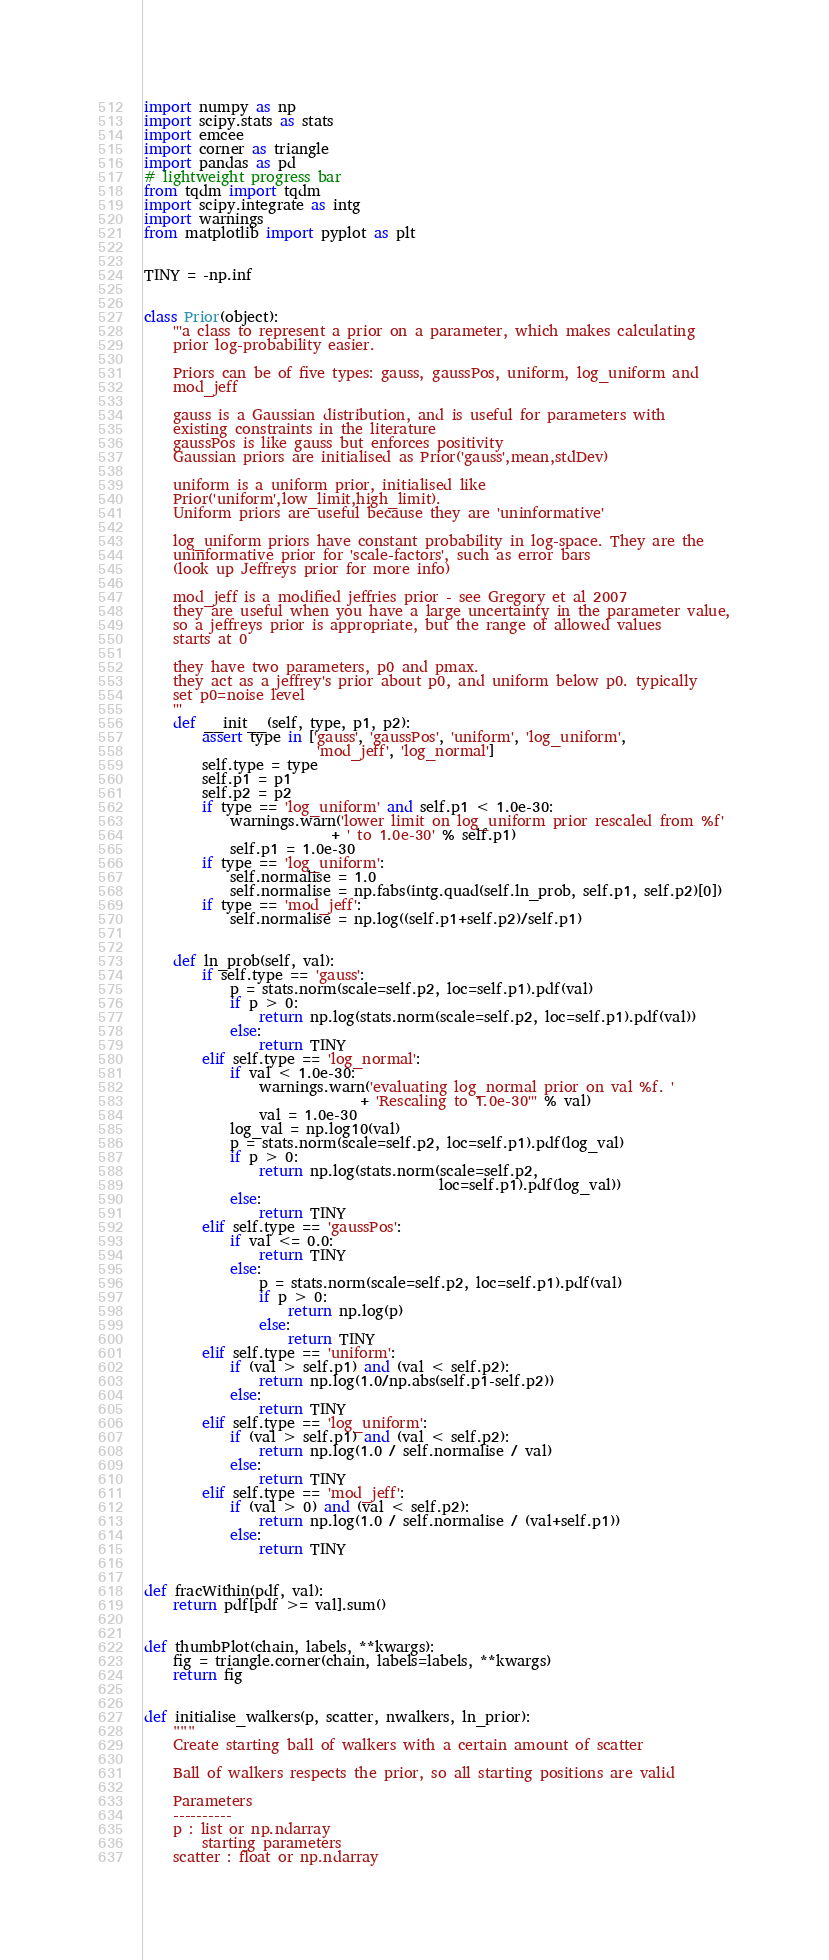<code> <loc_0><loc_0><loc_500><loc_500><_Python_>import numpy as np
import scipy.stats as stats
import emcee
import corner as triangle
import pandas as pd
# lightweight progress bar
from tqdm import tqdm
import scipy.integrate as intg
import warnings
from matplotlib import pyplot as plt


TINY = -np.inf


class Prior(object):
    '''a class to represent a prior on a parameter, which makes calculating
    prior log-probability easier.

    Priors can be of five types: gauss, gaussPos, uniform, log_uniform and
    mod_jeff

    gauss is a Gaussian distribution, and is useful for parameters with
    existing constraints in the literature
    gaussPos is like gauss but enforces positivity
    Gaussian priors are initialised as Prior('gauss',mean,stdDev)

    uniform is a uniform prior, initialised like
    Prior('uniform',low_limit,high_limit).
    Uniform priors are useful because they are 'uninformative'

    log_uniform priors have constant probability in log-space. They are the
    uninformative prior for 'scale-factors', such as error bars
    (look up Jeffreys prior for more info)

    mod_jeff is a modified jeffries prior - see Gregory et al 2007
    they are useful when you have a large uncertainty in the parameter value,
    so a jeffreys prior is appropriate, but the range of allowed values
    starts at 0

    they have two parameters, p0 and pmax.
    they act as a jeffrey's prior about p0, and uniform below p0. typically
    set p0=noise level
    '''
    def __init__(self, type, p1, p2):
        assert type in ['gauss', 'gaussPos', 'uniform', 'log_uniform',
                        'mod_jeff', 'log_normal']
        self.type = type
        self.p1 = p1
        self.p2 = p2
        if type == 'log_uniform' and self.p1 < 1.0e-30:
            warnings.warn('lower limit on log_uniform prior rescaled from %f'
                          + ' to 1.0e-30' % self.p1)
            self.p1 = 1.0e-30
        if type == 'log_uniform':
            self.normalise = 1.0
            self.normalise = np.fabs(intg.quad(self.ln_prob, self.p1, self.p2)[0])
        if type == 'mod_jeff':
            self.normalise = np.log((self.p1+self.p2)/self.p1)


    def ln_prob(self, val):
        if self.type == 'gauss':
            p = stats.norm(scale=self.p2, loc=self.p1).pdf(val)
            if p > 0:
                return np.log(stats.norm(scale=self.p2, loc=self.p1).pdf(val))
            else:
                return TINY
        elif self.type == 'log_normal':
            if val < 1.0e-30:
                warnings.warn('evaluating log_normal prior on val %f. '
                              + 'Rescaling to 1.0e-30''' % val)
                val = 1.0e-30
            log_val = np.log10(val)
            p = stats.norm(scale=self.p2, loc=self.p1).pdf(log_val)
            if p > 0:
                return np.log(stats.norm(scale=self.p2,
                                         loc=self.p1).pdf(log_val))
            else:
                return TINY
        elif self.type == 'gaussPos':
            if val <= 0.0:
                return TINY
            else:
                p = stats.norm(scale=self.p2, loc=self.p1).pdf(val)
                if p > 0:
                    return np.log(p)
                else:
                    return TINY
        elif self.type == 'uniform':
            if (val > self.p1) and (val < self.p2):
                return np.log(1.0/np.abs(self.p1-self.p2))
            else:
                return TINY
        elif self.type == 'log_uniform':
            if (val > self.p1) and (val < self.p2):
                return np.log(1.0 / self.normalise / val)
            else:
                return TINY
        elif self.type == 'mod_jeff':
            if (val > 0) and (val < self.p2):
                return np.log(1.0 / self.normalise / (val+self.p1))
            else:
                return TINY


def fracWithin(pdf, val):
    return pdf[pdf >= val].sum()


def thumbPlot(chain, labels, **kwargs):
    fig = triangle.corner(chain, labels=labels, **kwargs)
    return fig


def initialise_walkers(p, scatter, nwalkers, ln_prior):
    """
    Create starting ball of walkers with a certain amount of scatter

    Ball of walkers respects the prior, so all starting positions are valid

    Parameters
    ----------
    p : list or np.ndarray
        starting parameters
    scatter : float or np.ndarray</code> 